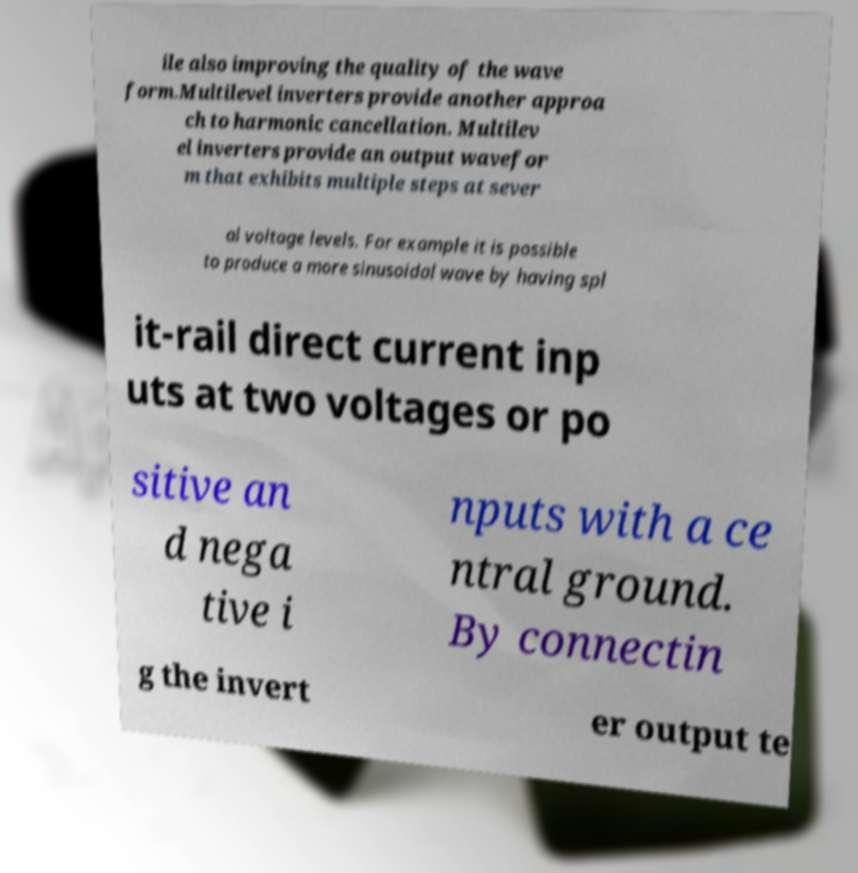What messages or text are displayed in this image? I need them in a readable, typed format. ile also improving the quality of the wave form.Multilevel inverters provide another approa ch to harmonic cancellation. Multilev el inverters provide an output wavefor m that exhibits multiple steps at sever al voltage levels. For example it is possible to produce a more sinusoidal wave by having spl it-rail direct current inp uts at two voltages or po sitive an d nega tive i nputs with a ce ntral ground. By connectin g the invert er output te 